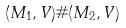<formula> <loc_0><loc_0><loc_500><loc_500>( M _ { 1 } , V ) \# ( M _ { 2 } , V )</formula> 